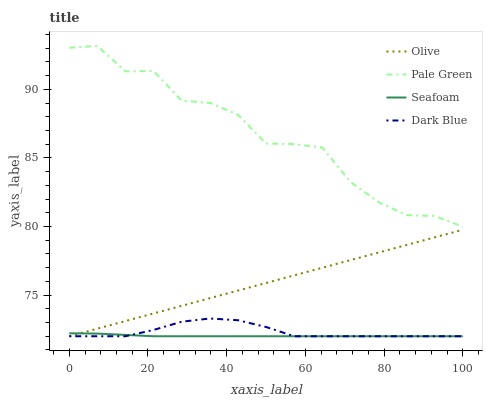Does Seafoam have the minimum area under the curve?
Answer yes or no. Yes. Does Pale Green have the maximum area under the curve?
Answer yes or no. Yes. Does Dark Blue have the minimum area under the curve?
Answer yes or no. No. Does Dark Blue have the maximum area under the curve?
Answer yes or no. No. Is Olive the smoothest?
Answer yes or no. Yes. Is Pale Green the roughest?
Answer yes or no. Yes. Is Dark Blue the smoothest?
Answer yes or no. No. Is Dark Blue the roughest?
Answer yes or no. No. Does Olive have the lowest value?
Answer yes or no. Yes. Does Pale Green have the lowest value?
Answer yes or no. No. Does Pale Green have the highest value?
Answer yes or no. Yes. Does Dark Blue have the highest value?
Answer yes or no. No. Is Olive less than Pale Green?
Answer yes or no. Yes. Is Pale Green greater than Seafoam?
Answer yes or no. Yes. Does Dark Blue intersect Olive?
Answer yes or no. Yes. Is Dark Blue less than Olive?
Answer yes or no. No. Is Dark Blue greater than Olive?
Answer yes or no. No. Does Olive intersect Pale Green?
Answer yes or no. No. 